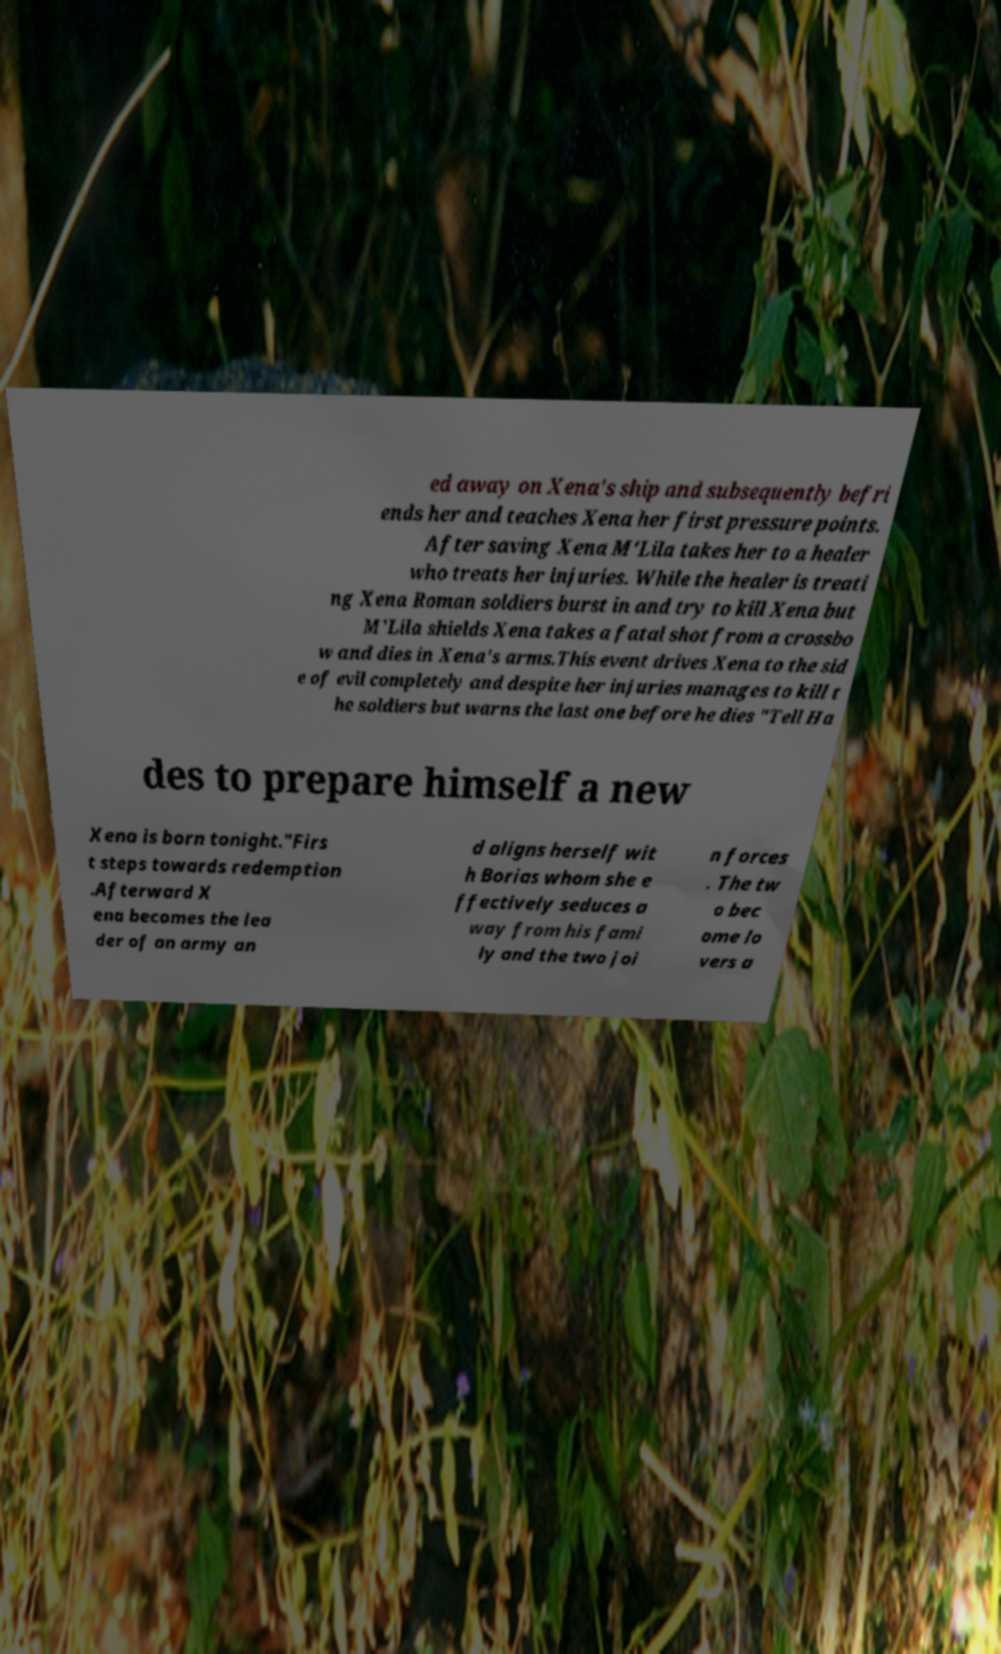Could you assist in decoding the text presented in this image and type it out clearly? ed away on Xena's ship and subsequently befri ends her and teaches Xena her first pressure points. After saving Xena M'Lila takes her to a healer who treats her injuries. While the healer is treati ng Xena Roman soldiers burst in and try to kill Xena but M'Lila shields Xena takes a fatal shot from a crossbo w and dies in Xena's arms.This event drives Xena to the sid e of evil completely and despite her injuries manages to kill t he soldiers but warns the last one before he dies "Tell Ha des to prepare himself a new Xena is born tonight."Firs t steps towards redemption .Afterward X ena becomes the lea der of an army an d aligns herself wit h Borias whom she e ffectively seduces a way from his fami ly and the two joi n forces . The tw o bec ome lo vers a 